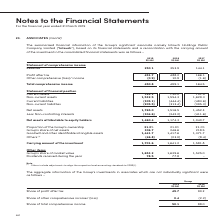According to Singapore Telecommunications's financial document, Which associate's information does this note contain? Intouch Holdings Public Company Limited. The document states: "ation of the Group’s significant associate namely Intouch Holdings Public Company Limited (“ Intouch ”), based on its financial statements and a recon..." Also, What information does the line item 'Others' relate to? adjustments to align the respective local accounting standards to SFRS(I). The document states: "(1) Others include adjustments to align the respective local accounting standards to SFRS(I)...." Also, What other information is provided other than financial information from the statement of comprehensive income and statement of financial position? The document shows two values: Group’s share of market value and Dividends received during the year. From the document: "p’s share of market value 1,653.2 1,639.6 1,525.0 Dividends received during the year 78.5 77.8 - Other items Group’s share of market value 1,653.2 1,6..." Also, can you calculate: What is the % change in carrying amount from 2017 to 2019? To answer this question, I need to perform calculations using the financial data. The calculation is:  (1,701.6 - 1,581.8) / 1,581.8, which equals 7.57 (percentage). This is based on the information: "Carrying amount of the investment 1,701.6 1,641.2 1,581.8 Carrying amount of the investment 1,701.6 1,641.2 1,581.8..." The key data points involved are: 1,581.8, 1,701.6. Additionally, In which year was the total comprehensive income the highest? According to the financial document, 2018. The relevant text states: "2019 S$ Mil 2018 S$ Mil 2017 S$ Mil..." Also, How many different categories of items are there in the statement of financial position? Counting the relevant items in the document: Current assets, Non-current assets, Current Liabilities, Non-current liabilities , I find 4 instances. The key data points involved are: Current Liabilities, Current assets, Non-current assets. 